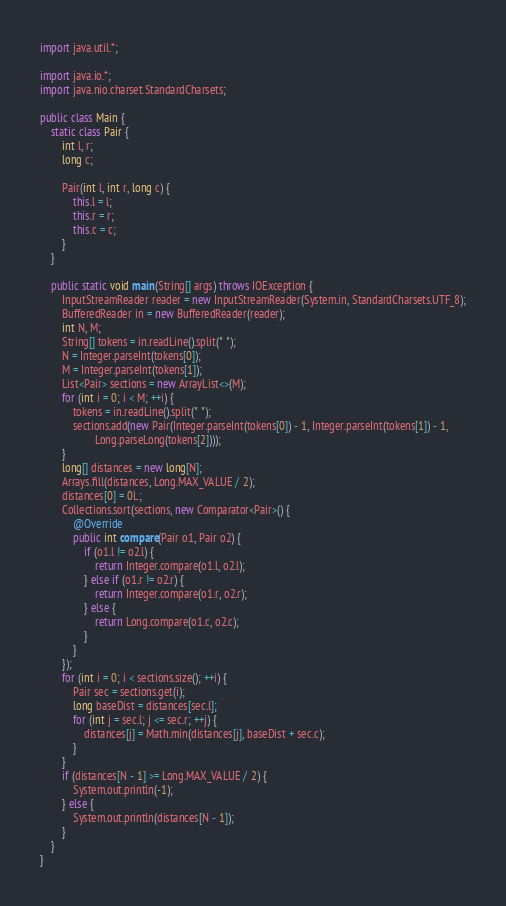Convert code to text. <code><loc_0><loc_0><loc_500><loc_500><_Java_>import java.util.*;

import java.io.*;
import java.nio.charset.StandardCharsets;

public class Main {
	static class Pair {
		int l, r;
		long c;

		Pair(int l, int r, long c) {
			this.l = l;
			this.r = r;
			this.c = c;
		}
	}

	public static void main(String[] args) throws IOException {
		InputStreamReader reader = new InputStreamReader(System.in, StandardCharsets.UTF_8);
		BufferedReader in = new BufferedReader(reader);
		int N, M;
		String[] tokens = in.readLine().split(" ");
		N = Integer.parseInt(tokens[0]);
		M = Integer.parseInt(tokens[1]);
		List<Pair> sections = new ArrayList<>(M);
		for (int i = 0; i < M; ++i) {
			tokens = in.readLine().split(" ");
			sections.add(new Pair(Integer.parseInt(tokens[0]) - 1, Integer.parseInt(tokens[1]) - 1,
					Long.parseLong(tokens[2])));
		}
		long[] distances = new long[N];
		Arrays.fill(distances, Long.MAX_VALUE / 2);
		distances[0] = 0L;
		Collections.sort(sections, new Comparator<Pair>() {
			@Override
			public int compare(Pair o1, Pair o2) {
				if (o1.l != o2.l) {
					return Integer.compare(o1.l, o2.l);
				} else if (o1.r != o2.r) {
					return Integer.compare(o1.r, o2.r);
				} else {
					return Long.compare(o1.c, o2.c);
				}
			}
		});
		for (int i = 0; i < sections.size(); ++i) {
			Pair sec = sections.get(i);
			long baseDist = distances[sec.l];
			for (int j = sec.l; j <= sec.r; ++j) {
				distances[j] = Math.min(distances[j], baseDist + sec.c);
			}
		}
		if (distances[N - 1] >= Long.MAX_VALUE / 2) {
			System.out.println(-1);
		} else {
			System.out.println(distances[N - 1]);
		}
	}
}</code> 